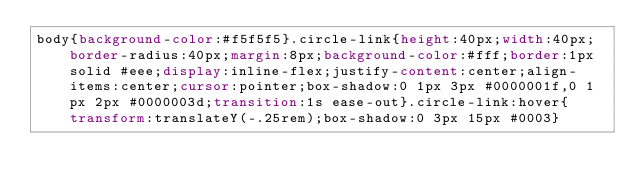<code> <loc_0><loc_0><loc_500><loc_500><_CSS_>body{background-color:#f5f5f5}.circle-link{height:40px;width:40px;border-radius:40px;margin:8px;background-color:#fff;border:1px solid #eee;display:inline-flex;justify-content:center;align-items:center;cursor:pointer;box-shadow:0 1px 3px #0000001f,0 1px 2px #0000003d;transition:1s ease-out}.circle-link:hover{transform:translateY(-.25rem);box-shadow:0 3px 15px #0003}</code> 